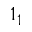<formula> <loc_0><loc_0><loc_500><loc_500>1 _ { 1 }</formula> 